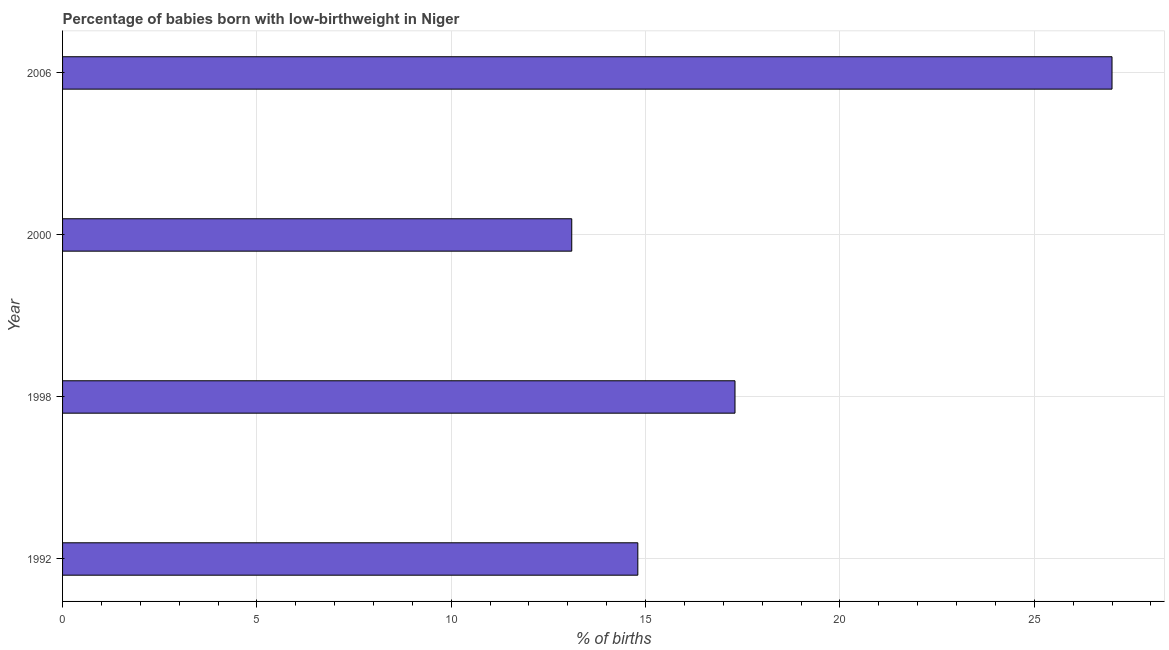What is the title of the graph?
Keep it short and to the point. Percentage of babies born with low-birthweight in Niger. What is the label or title of the X-axis?
Keep it short and to the point. % of births. What is the label or title of the Y-axis?
Your answer should be compact. Year. What is the percentage of babies who were born with low-birthweight in 2000?
Provide a short and direct response. 13.1. Across all years, what is the minimum percentage of babies who were born with low-birthweight?
Provide a short and direct response. 13.1. In which year was the percentage of babies who were born with low-birthweight minimum?
Your answer should be compact. 2000. What is the sum of the percentage of babies who were born with low-birthweight?
Your answer should be compact. 72.2. What is the average percentage of babies who were born with low-birthweight per year?
Ensure brevity in your answer.  18.05. What is the median percentage of babies who were born with low-birthweight?
Offer a very short reply. 16.05. In how many years, is the percentage of babies who were born with low-birthweight greater than 6 %?
Give a very brief answer. 4. What is the ratio of the percentage of babies who were born with low-birthweight in 1998 to that in 2000?
Your response must be concise. 1.32. Is the percentage of babies who were born with low-birthweight in 1992 less than that in 1998?
Give a very brief answer. Yes. What is the difference between the highest and the second highest percentage of babies who were born with low-birthweight?
Your answer should be compact. 9.7. In how many years, is the percentage of babies who were born with low-birthweight greater than the average percentage of babies who were born with low-birthweight taken over all years?
Your answer should be very brief. 1. How many bars are there?
Your answer should be compact. 4. Are all the bars in the graph horizontal?
Your response must be concise. Yes. How many years are there in the graph?
Your response must be concise. 4. What is the % of births of 1998?
Keep it short and to the point. 17.3. What is the difference between the % of births in 1992 and 1998?
Your response must be concise. -2.5. What is the difference between the % of births in 1992 and 2006?
Keep it short and to the point. -12.2. What is the ratio of the % of births in 1992 to that in 1998?
Offer a very short reply. 0.85. What is the ratio of the % of births in 1992 to that in 2000?
Offer a very short reply. 1.13. What is the ratio of the % of births in 1992 to that in 2006?
Keep it short and to the point. 0.55. What is the ratio of the % of births in 1998 to that in 2000?
Your response must be concise. 1.32. What is the ratio of the % of births in 1998 to that in 2006?
Keep it short and to the point. 0.64. What is the ratio of the % of births in 2000 to that in 2006?
Provide a short and direct response. 0.48. 